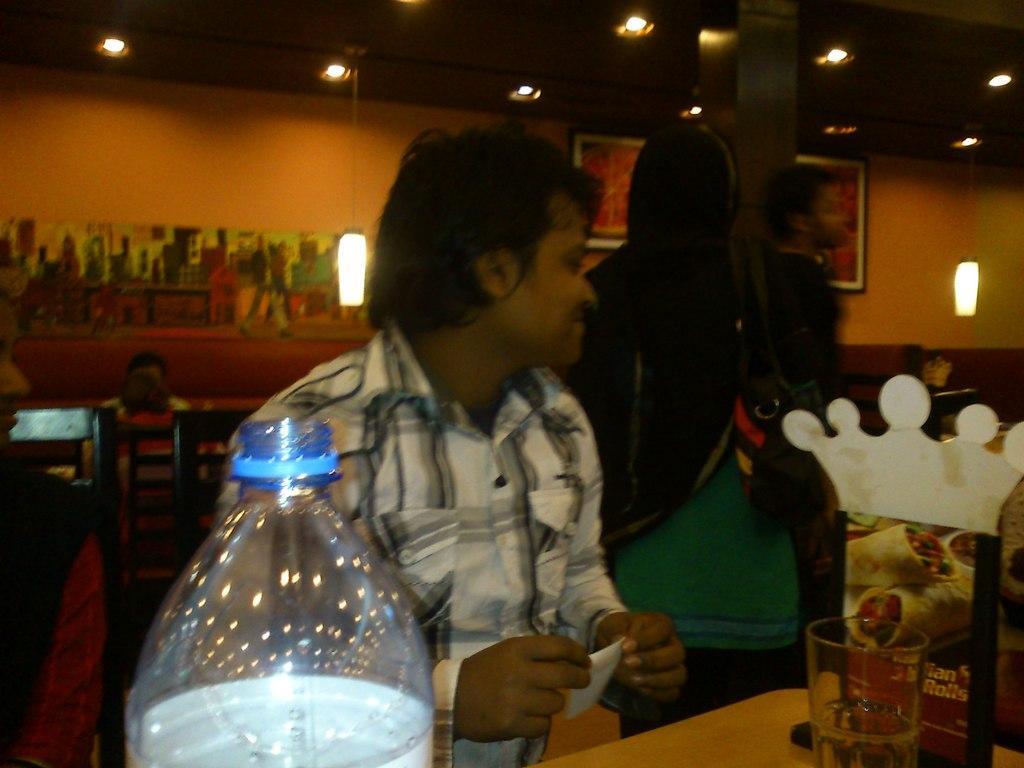Can you describe this image briefly? This picture is taken inside the restaurant in which there is a man sitting near the table. On the table there is glass and a water bottle. Beside the man there is another woman who is standing by holding a hand bag. To the wall there is photo frame and at the top there is ceiling with the lights in between them. 